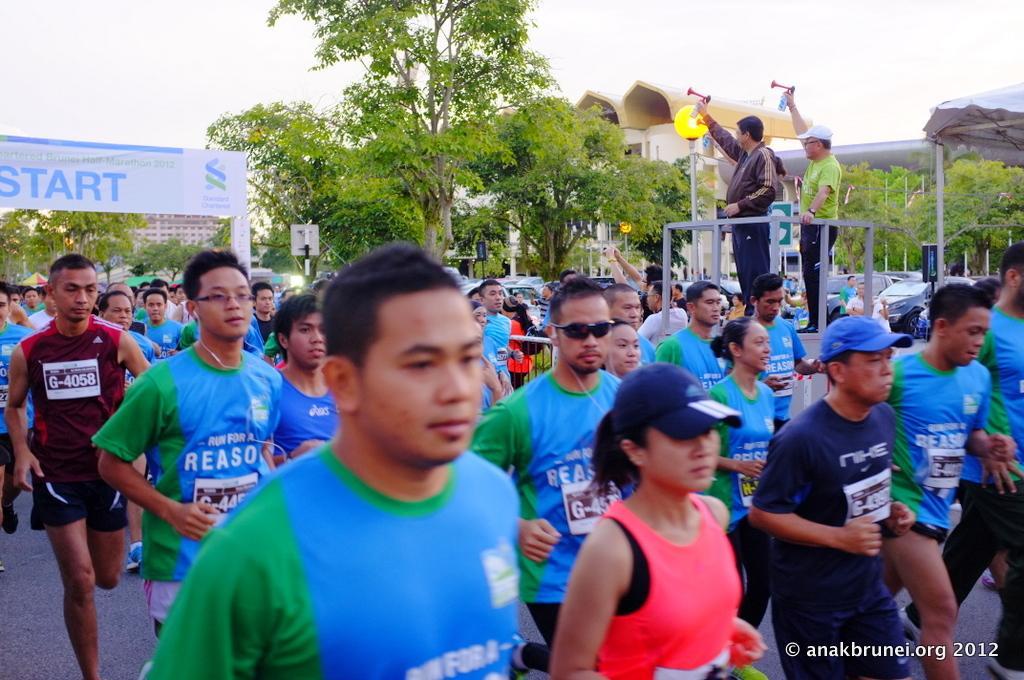Please provide a concise description of this image. In this image, I can see a group of people running on the road and there are two persons standing on a platform and holding the objects. In the background there are trees, buildings, vehicles, a banner, boards to the poles and I can see the sky. On the right side of the image, it looks like a tent. In the bottom right corner of the image, I can see a watermark. 